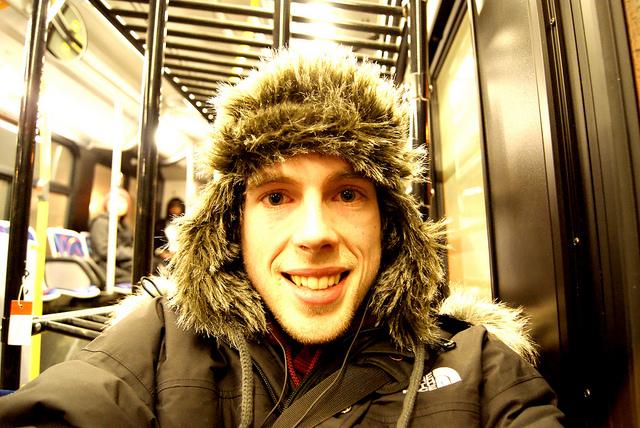What brand is his coat?
Keep it brief. North face. Is he alone?
Short answer required. No. Is this a "selfie"?
Answer briefly. Yes. 